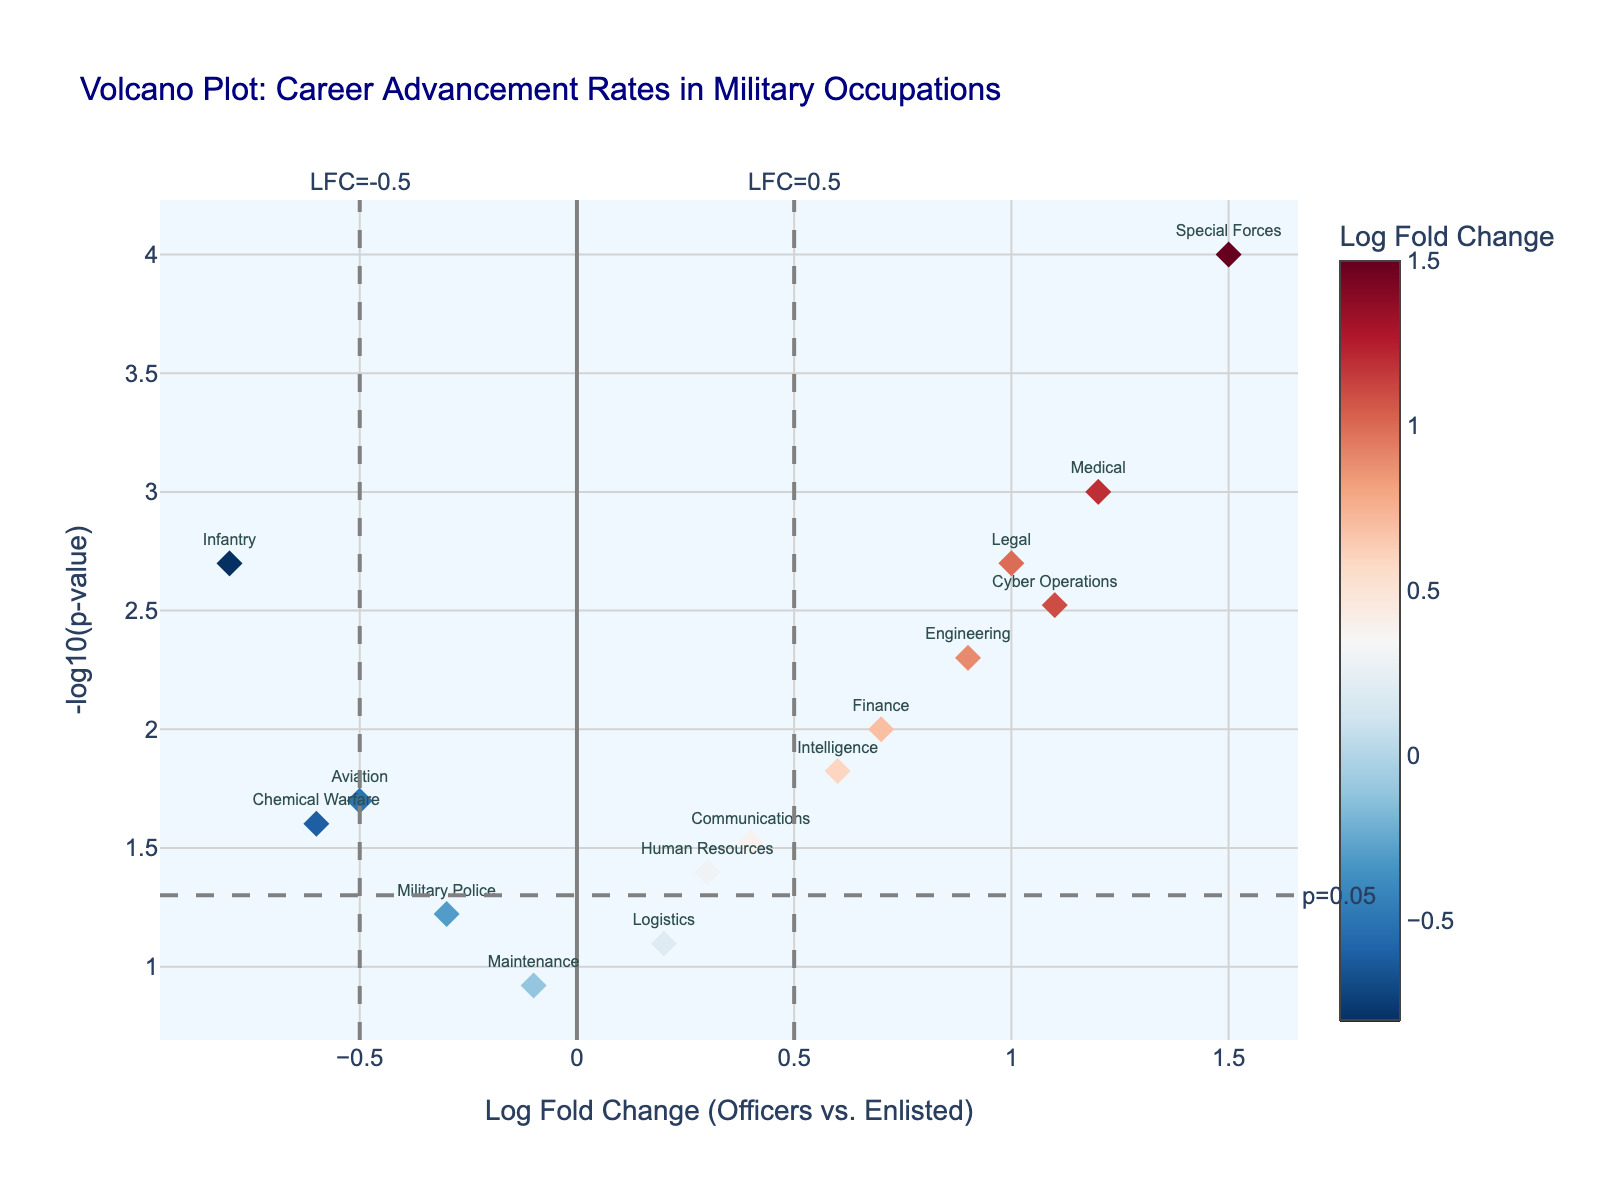How many occupations have a significant p-value? Significant p-values are typically those less than 0.05, which corresponds to points above the horizontal threshold line at y = -log10(0.05). By counting the points above this line, we identify 11 significant occupations.
Answer: 11 Which occupation has the highest -log10(p-value)? Look for the point positioned highest on the y-axis. Special Forces is the occupation with the highest -log10(p-value).
Answer: Special Forces What is the Log Fold Change for the Medical occupation? Find the "Medical" data point on the plot and observe its x-coordinate value. The Log Fold Change for Medical is 1.2.
Answer: 1.2 Which occupation has the lowest Log Fold Change value? Identify the point furthest to the left on the x-axis, which represents the most negative Log Fold Change. The Infantry has the lowest Log Fold Change at -0.8.
Answer: Infantry Are there more occupations with positive or negative Log Fold Change values? Count the points with positive x-values and negative x-values separately. Seven points are on the positive side and eight on the negative side. There are more occupations with negative Log Fold Change values.
Answer: Negative Which occupation lies closest to the vertical threshold line at Log Fold Change = 0.5? Locate the line at x = 0.5 and identify the closest point using visual distance. The Medical occupation lies closest to this line.
Answer: Medical What is the -log10(p-value) for the Legal occupation? Find the "Legal" data point on the plot and observe its y-coordinate value. The -log10(p-value) for Legal is approximately 2.7.
Answer: 2.7 Which occupations are within the threshold range of Log Fold Change between -0.5 and 0.5? Look at points within the vertical lines at x = -0.5 and x = 0.5. Logistics, Communications, Military Police, Maintenance, and Human Resources are in this range.
Answer: Logistics, Communications, Military Police, Maintenance, Human Resources What is the average Log Fold Change for Communication and Finance occupations? Find the Log Fold Change values for both occupations and calculate their average. Communications has a Log Fold Change of 0.4, and Finance has 0.7. The average is (0.4 + 0.7) / 2 = 0.55.
Answer: 0.55 Which occupation is highlighted by the highest color intensity? Identify the data point with the most intense color, indicating the highest or lowest Log Fold Change value. Special Forces has the highest color intensity with a Log Fold Change of 1.5.
Answer: Special Forces 